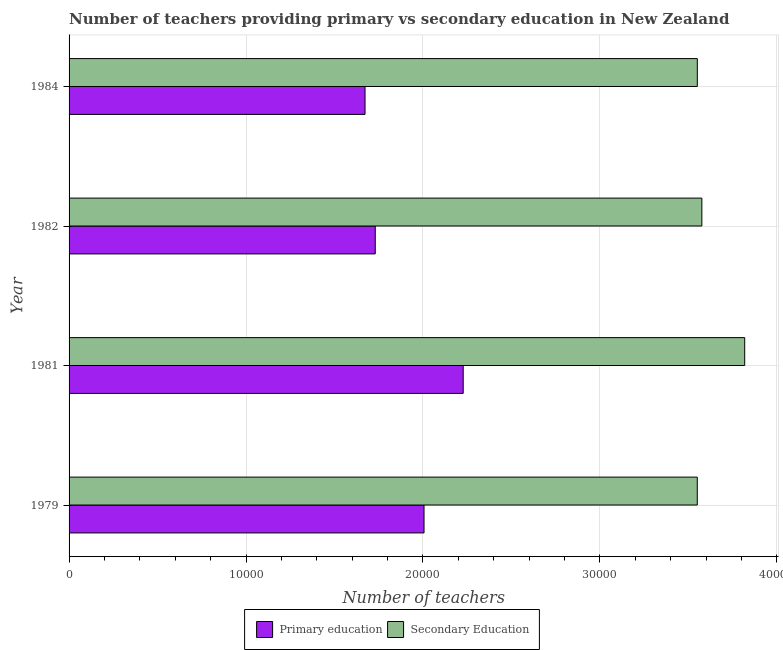How many groups of bars are there?
Give a very brief answer. 4. How many bars are there on the 1st tick from the top?
Your response must be concise. 2. What is the number of primary teachers in 1981?
Offer a very short reply. 2.23e+04. Across all years, what is the maximum number of secondary teachers?
Provide a succinct answer. 3.82e+04. Across all years, what is the minimum number of primary teachers?
Ensure brevity in your answer.  1.67e+04. What is the total number of secondary teachers in the graph?
Offer a terse response. 1.45e+05. What is the difference between the number of primary teachers in 1979 and that in 1982?
Offer a very short reply. 2757. What is the difference between the number of secondary teachers in 1984 and the number of primary teachers in 1979?
Your answer should be compact. 1.54e+04. What is the average number of secondary teachers per year?
Keep it short and to the point. 3.62e+04. In the year 1981, what is the difference between the number of primary teachers and number of secondary teachers?
Offer a terse response. -1.59e+04. In how many years, is the number of primary teachers greater than 16000 ?
Give a very brief answer. 4. What is the difference between the highest and the second highest number of primary teachers?
Ensure brevity in your answer.  2214. What is the difference between the highest and the lowest number of primary teachers?
Offer a terse response. 5549. In how many years, is the number of secondary teachers greater than the average number of secondary teachers taken over all years?
Provide a short and direct response. 1. What does the 2nd bar from the top in 1984 represents?
Offer a very short reply. Primary education. What does the 2nd bar from the bottom in 1981 represents?
Provide a short and direct response. Secondary Education. How many years are there in the graph?
Your answer should be compact. 4. Does the graph contain any zero values?
Make the answer very short. No. Where does the legend appear in the graph?
Provide a short and direct response. Bottom center. How are the legend labels stacked?
Your answer should be very brief. Horizontal. What is the title of the graph?
Keep it short and to the point. Number of teachers providing primary vs secondary education in New Zealand. Does "Secondary school" appear as one of the legend labels in the graph?
Give a very brief answer. No. What is the label or title of the X-axis?
Provide a short and direct response. Number of teachers. What is the Number of teachers of Primary education in 1979?
Provide a succinct answer. 2.01e+04. What is the Number of teachers in Secondary Education in 1979?
Your answer should be compact. 3.55e+04. What is the Number of teachers in Primary education in 1981?
Ensure brevity in your answer.  2.23e+04. What is the Number of teachers of Secondary Education in 1981?
Your response must be concise. 3.82e+04. What is the Number of teachers in Primary education in 1982?
Your answer should be compact. 1.73e+04. What is the Number of teachers in Secondary Education in 1982?
Provide a short and direct response. 3.58e+04. What is the Number of teachers of Primary education in 1984?
Provide a succinct answer. 1.67e+04. What is the Number of teachers in Secondary Education in 1984?
Your answer should be compact. 3.55e+04. Across all years, what is the maximum Number of teachers of Primary education?
Your answer should be very brief. 2.23e+04. Across all years, what is the maximum Number of teachers of Secondary Education?
Your response must be concise. 3.82e+04. Across all years, what is the minimum Number of teachers in Primary education?
Your response must be concise. 1.67e+04. Across all years, what is the minimum Number of teachers in Secondary Education?
Your response must be concise. 3.55e+04. What is the total Number of teachers of Primary education in the graph?
Your answer should be very brief. 7.64e+04. What is the total Number of teachers in Secondary Education in the graph?
Provide a succinct answer. 1.45e+05. What is the difference between the Number of teachers of Primary education in 1979 and that in 1981?
Provide a short and direct response. -2214. What is the difference between the Number of teachers of Secondary Education in 1979 and that in 1981?
Ensure brevity in your answer.  -2681. What is the difference between the Number of teachers of Primary education in 1979 and that in 1982?
Provide a succinct answer. 2757. What is the difference between the Number of teachers in Secondary Education in 1979 and that in 1982?
Your answer should be very brief. -259. What is the difference between the Number of teachers of Primary education in 1979 and that in 1984?
Give a very brief answer. 3335. What is the difference between the Number of teachers of Primary education in 1981 and that in 1982?
Your response must be concise. 4971. What is the difference between the Number of teachers in Secondary Education in 1981 and that in 1982?
Provide a succinct answer. 2422. What is the difference between the Number of teachers in Primary education in 1981 and that in 1984?
Keep it short and to the point. 5549. What is the difference between the Number of teachers in Secondary Education in 1981 and that in 1984?
Provide a succinct answer. 2679. What is the difference between the Number of teachers of Primary education in 1982 and that in 1984?
Give a very brief answer. 578. What is the difference between the Number of teachers of Secondary Education in 1982 and that in 1984?
Make the answer very short. 257. What is the difference between the Number of teachers of Primary education in 1979 and the Number of teachers of Secondary Education in 1981?
Your answer should be compact. -1.81e+04. What is the difference between the Number of teachers of Primary education in 1979 and the Number of teachers of Secondary Education in 1982?
Make the answer very short. -1.57e+04. What is the difference between the Number of teachers in Primary education in 1979 and the Number of teachers in Secondary Education in 1984?
Make the answer very short. -1.54e+04. What is the difference between the Number of teachers in Primary education in 1981 and the Number of teachers in Secondary Education in 1982?
Your answer should be compact. -1.35e+04. What is the difference between the Number of teachers of Primary education in 1981 and the Number of teachers of Secondary Education in 1984?
Your answer should be very brief. -1.32e+04. What is the difference between the Number of teachers of Primary education in 1982 and the Number of teachers of Secondary Education in 1984?
Give a very brief answer. -1.82e+04. What is the average Number of teachers of Primary education per year?
Ensure brevity in your answer.  1.91e+04. What is the average Number of teachers in Secondary Education per year?
Offer a terse response. 3.62e+04. In the year 1979, what is the difference between the Number of teachers in Primary education and Number of teachers in Secondary Education?
Keep it short and to the point. -1.54e+04. In the year 1981, what is the difference between the Number of teachers in Primary education and Number of teachers in Secondary Education?
Offer a terse response. -1.59e+04. In the year 1982, what is the difference between the Number of teachers in Primary education and Number of teachers in Secondary Education?
Your answer should be compact. -1.85e+04. In the year 1984, what is the difference between the Number of teachers in Primary education and Number of teachers in Secondary Education?
Your answer should be very brief. -1.88e+04. What is the ratio of the Number of teachers of Primary education in 1979 to that in 1981?
Ensure brevity in your answer.  0.9. What is the ratio of the Number of teachers of Secondary Education in 1979 to that in 1981?
Offer a very short reply. 0.93. What is the ratio of the Number of teachers in Primary education in 1979 to that in 1982?
Provide a short and direct response. 1.16. What is the ratio of the Number of teachers in Primary education in 1979 to that in 1984?
Keep it short and to the point. 1.2. What is the ratio of the Number of teachers in Secondary Education in 1979 to that in 1984?
Give a very brief answer. 1. What is the ratio of the Number of teachers in Primary education in 1981 to that in 1982?
Provide a short and direct response. 1.29. What is the ratio of the Number of teachers in Secondary Education in 1981 to that in 1982?
Ensure brevity in your answer.  1.07. What is the ratio of the Number of teachers in Primary education in 1981 to that in 1984?
Your response must be concise. 1.33. What is the ratio of the Number of teachers in Secondary Education in 1981 to that in 1984?
Your response must be concise. 1.08. What is the ratio of the Number of teachers in Primary education in 1982 to that in 1984?
Give a very brief answer. 1.03. What is the difference between the highest and the second highest Number of teachers in Primary education?
Offer a very short reply. 2214. What is the difference between the highest and the second highest Number of teachers of Secondary Education?
Provide a succinct answer. 2422. What is the difference between the highest and the lowest Number of teachers of Primary education?
Make the answer very short. 5549. What is the difference between the highest and the lowest Number of teachers of Secondary Education?
Ensure brevity in your answer.  2681. 